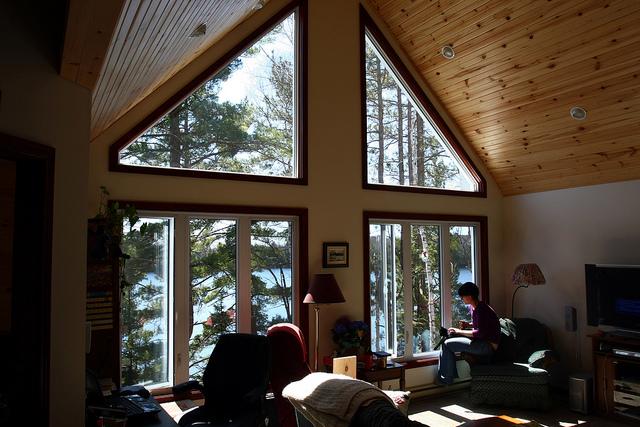How many windows do you see?
Answer briefly. 4. Is there any people?
Answer briefly. Yes. What is the roof made of?
Quick response, please. Wood. Are there blinds on the window?
Keep it brief. No. Is this an airport?
Answer briefly. No. Where was this photo taken?
Be succinct. Indoors. 